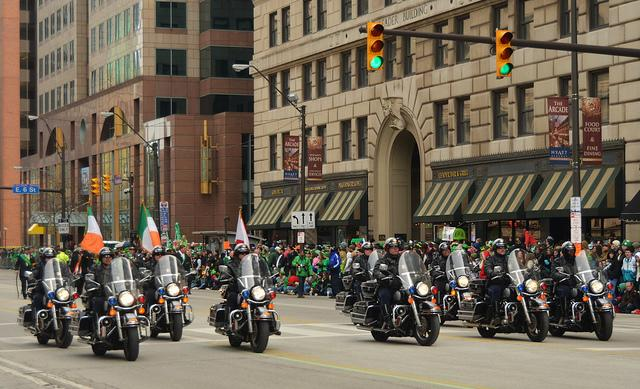Which nation is the motorcade of police motorcycles celebrating?

Choices:
A) ireland
B) italy
C) ivory coast
D) mexico ireland 